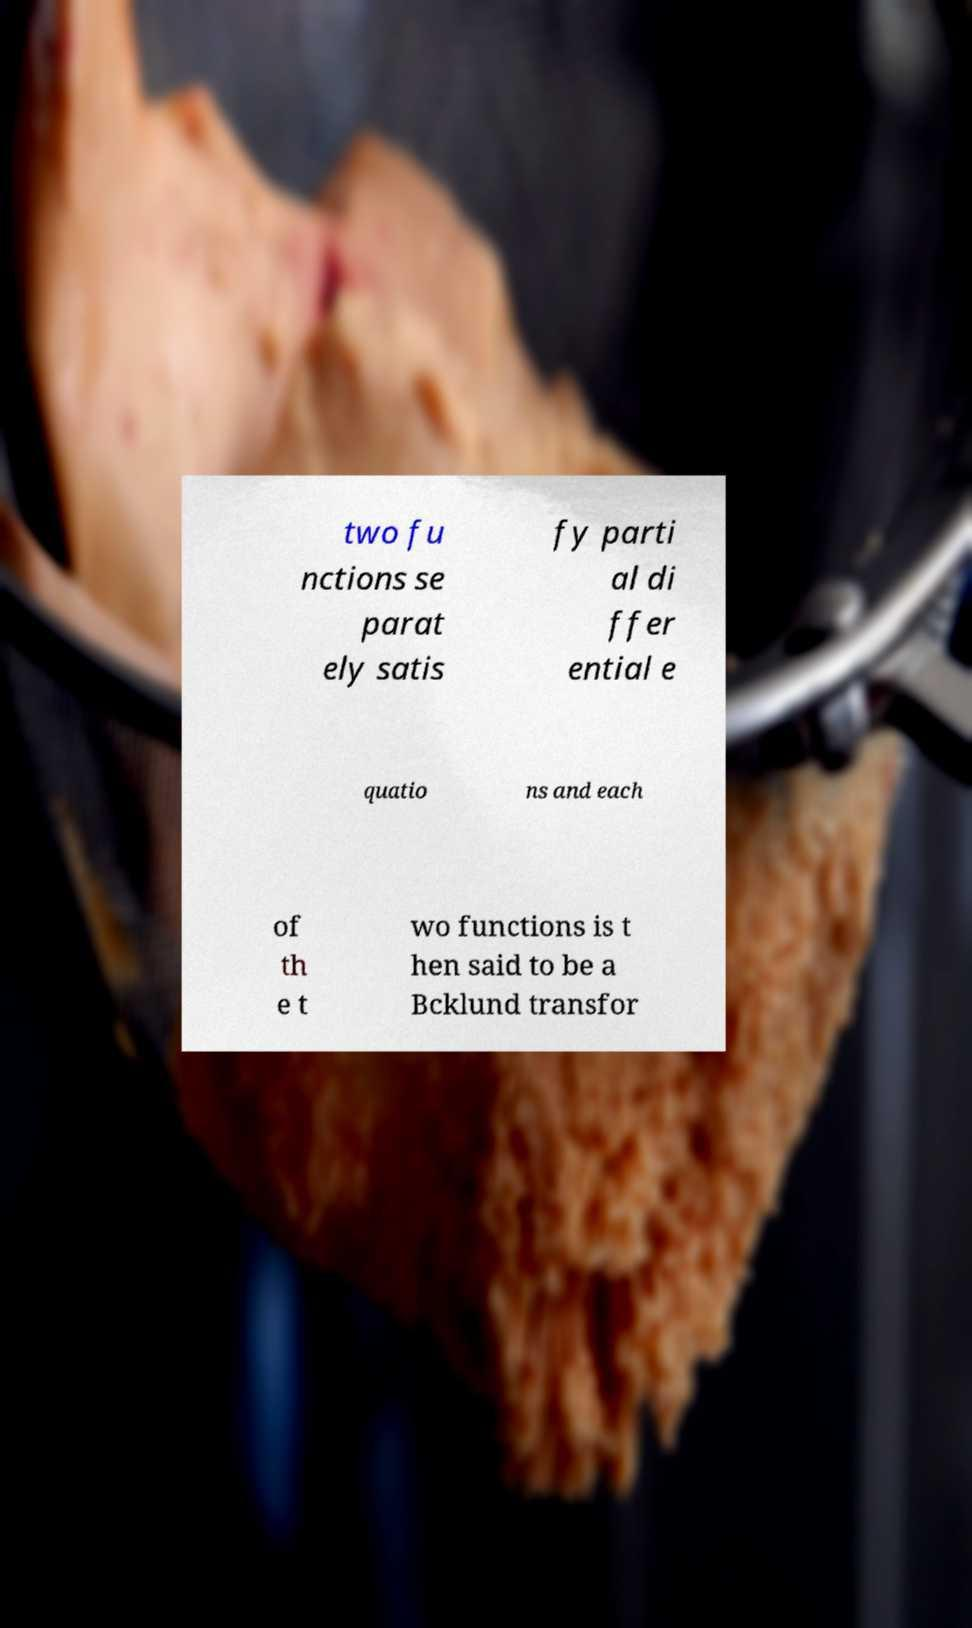Please identify and transcribe the text found in this image. two fu nctions se parat ely satis fy parti al di ffer ential e quatio ns and each of th e t wo functions is t hen said to be a Bcklund transfor 